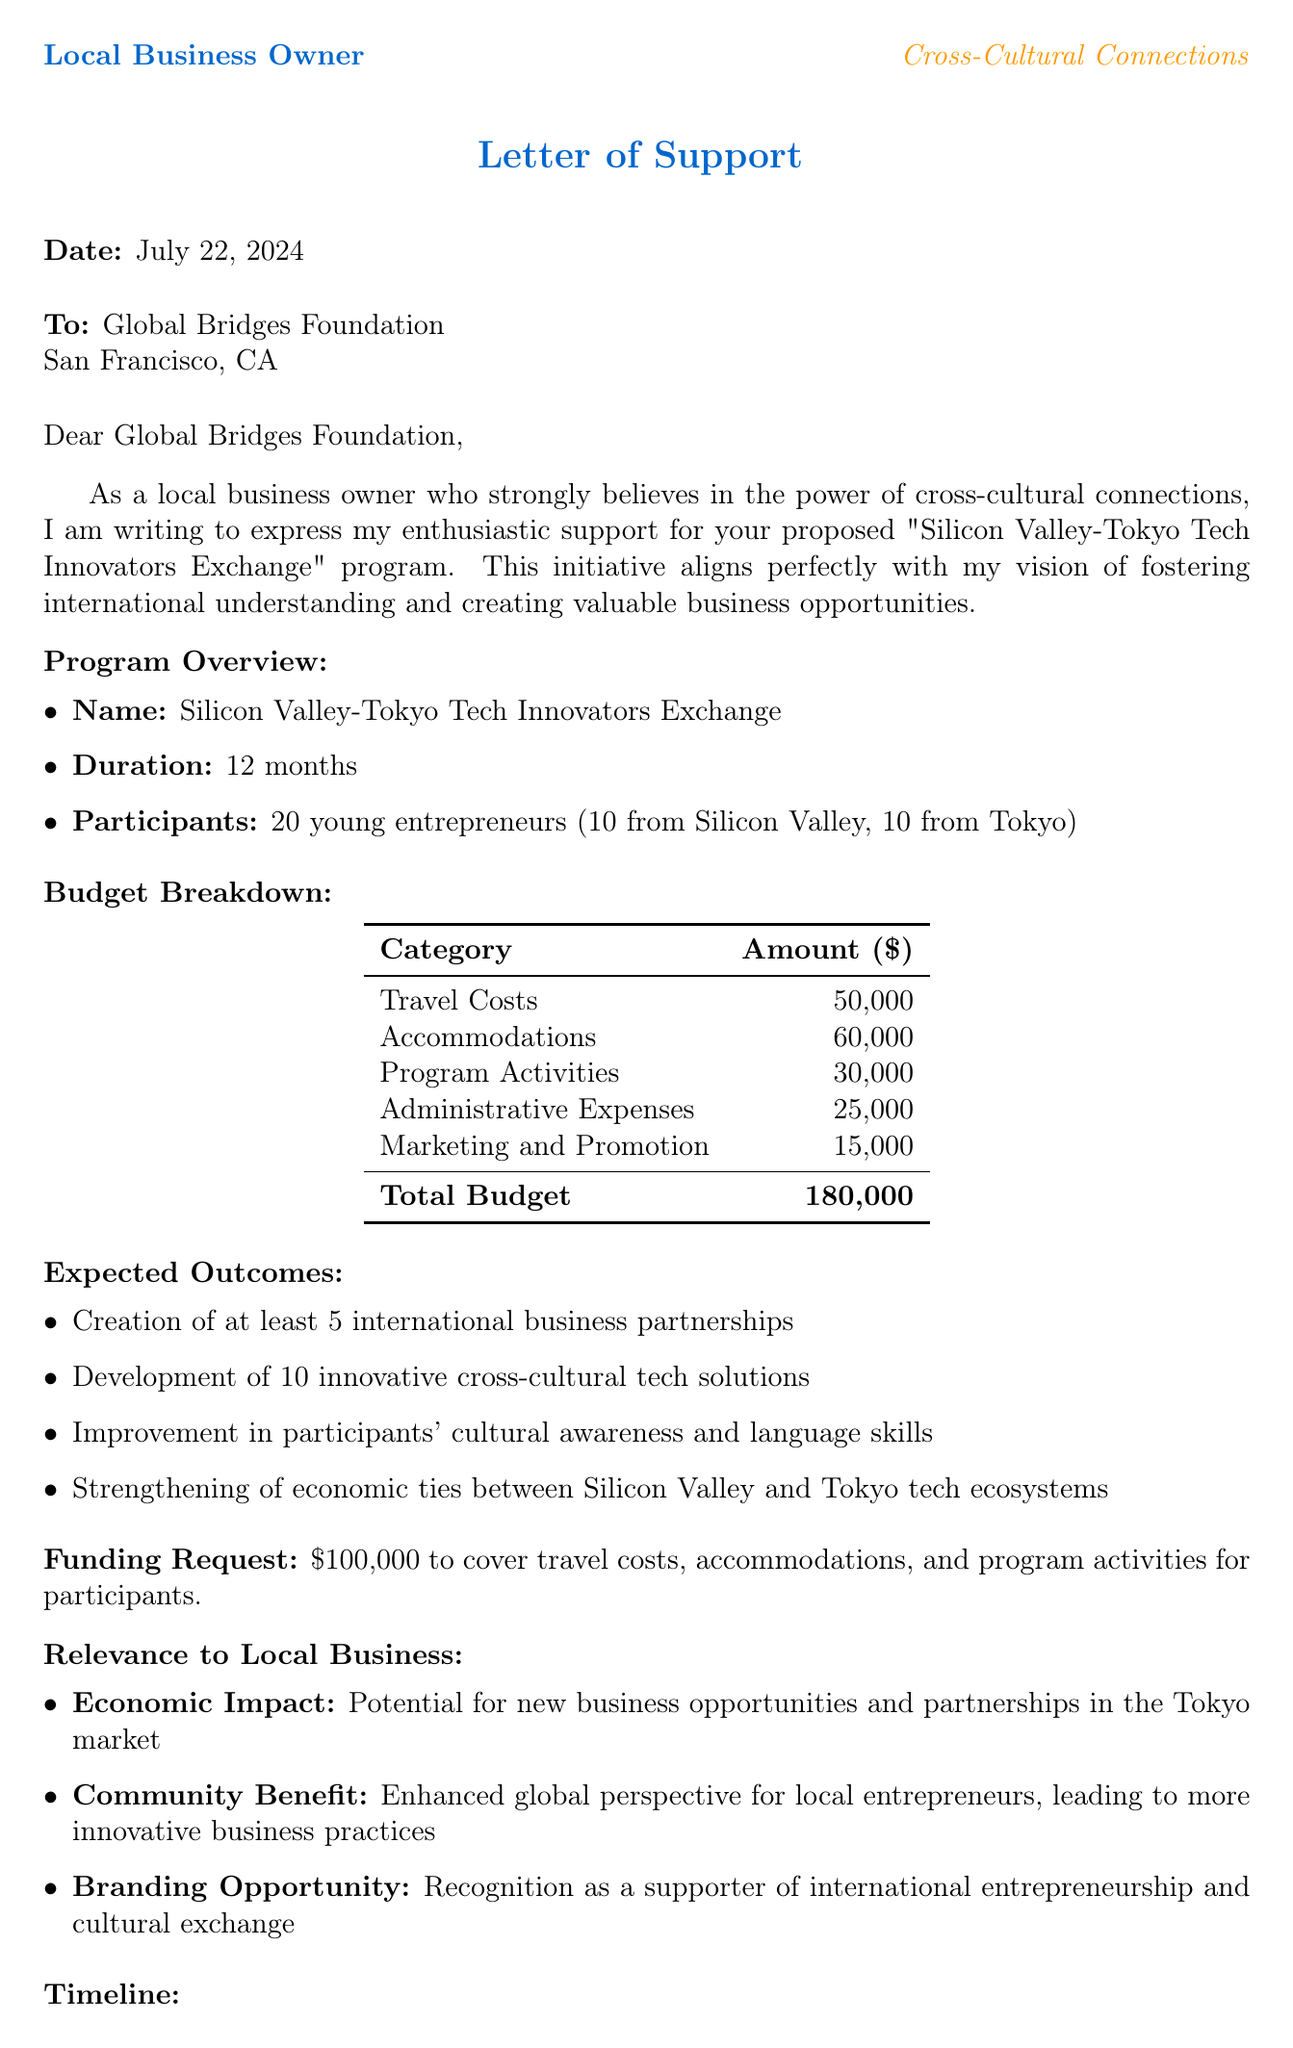What is the duration of the program? The duration of the program is specified as 12 months in the document.
Answer: 12 months What is the total budget requested for the initiative? The total budget requested for the initiative is found in the budget breakdown section, which totals $180,000.
Answer: 180,000 What is the name of the partner organization? The name of the partner organization, as presented in the document, is Global Bridges Foundation.
Answer: Global Bridges Foundation How many young entrepreneurs will participate? The document states that there will be 20 young entrepreneurs participating in the program.
Answer: 20 What are the expected outcomes related to cultural awareness? One of the expected outcomes is an improvement in participants' cultural awareness and language skills.
Answer: Improvement in participants' cultural awareness and language skills What is the application deadline for the program? The application deadline is outlined in the timeline section, which states it as September 1, 2023.
Answer: September 1, 2023 What type of opportunities for local businesses are mentioned in the proposal? The proposal mentions mentorship from local business leaders as one of the partnership opportunities.
Answer: Mentorship from local business leaders Who is a testimonial giver from TechFusion Inc.? The testimonial is given by Sarah Chen, the CEO of TechFusion Inc.
Answer: Sarah Chen What specific funding amount is requested? The specific amount requested for funding is highlighted in the funding request section as $100,000.
Answer: 100,000 